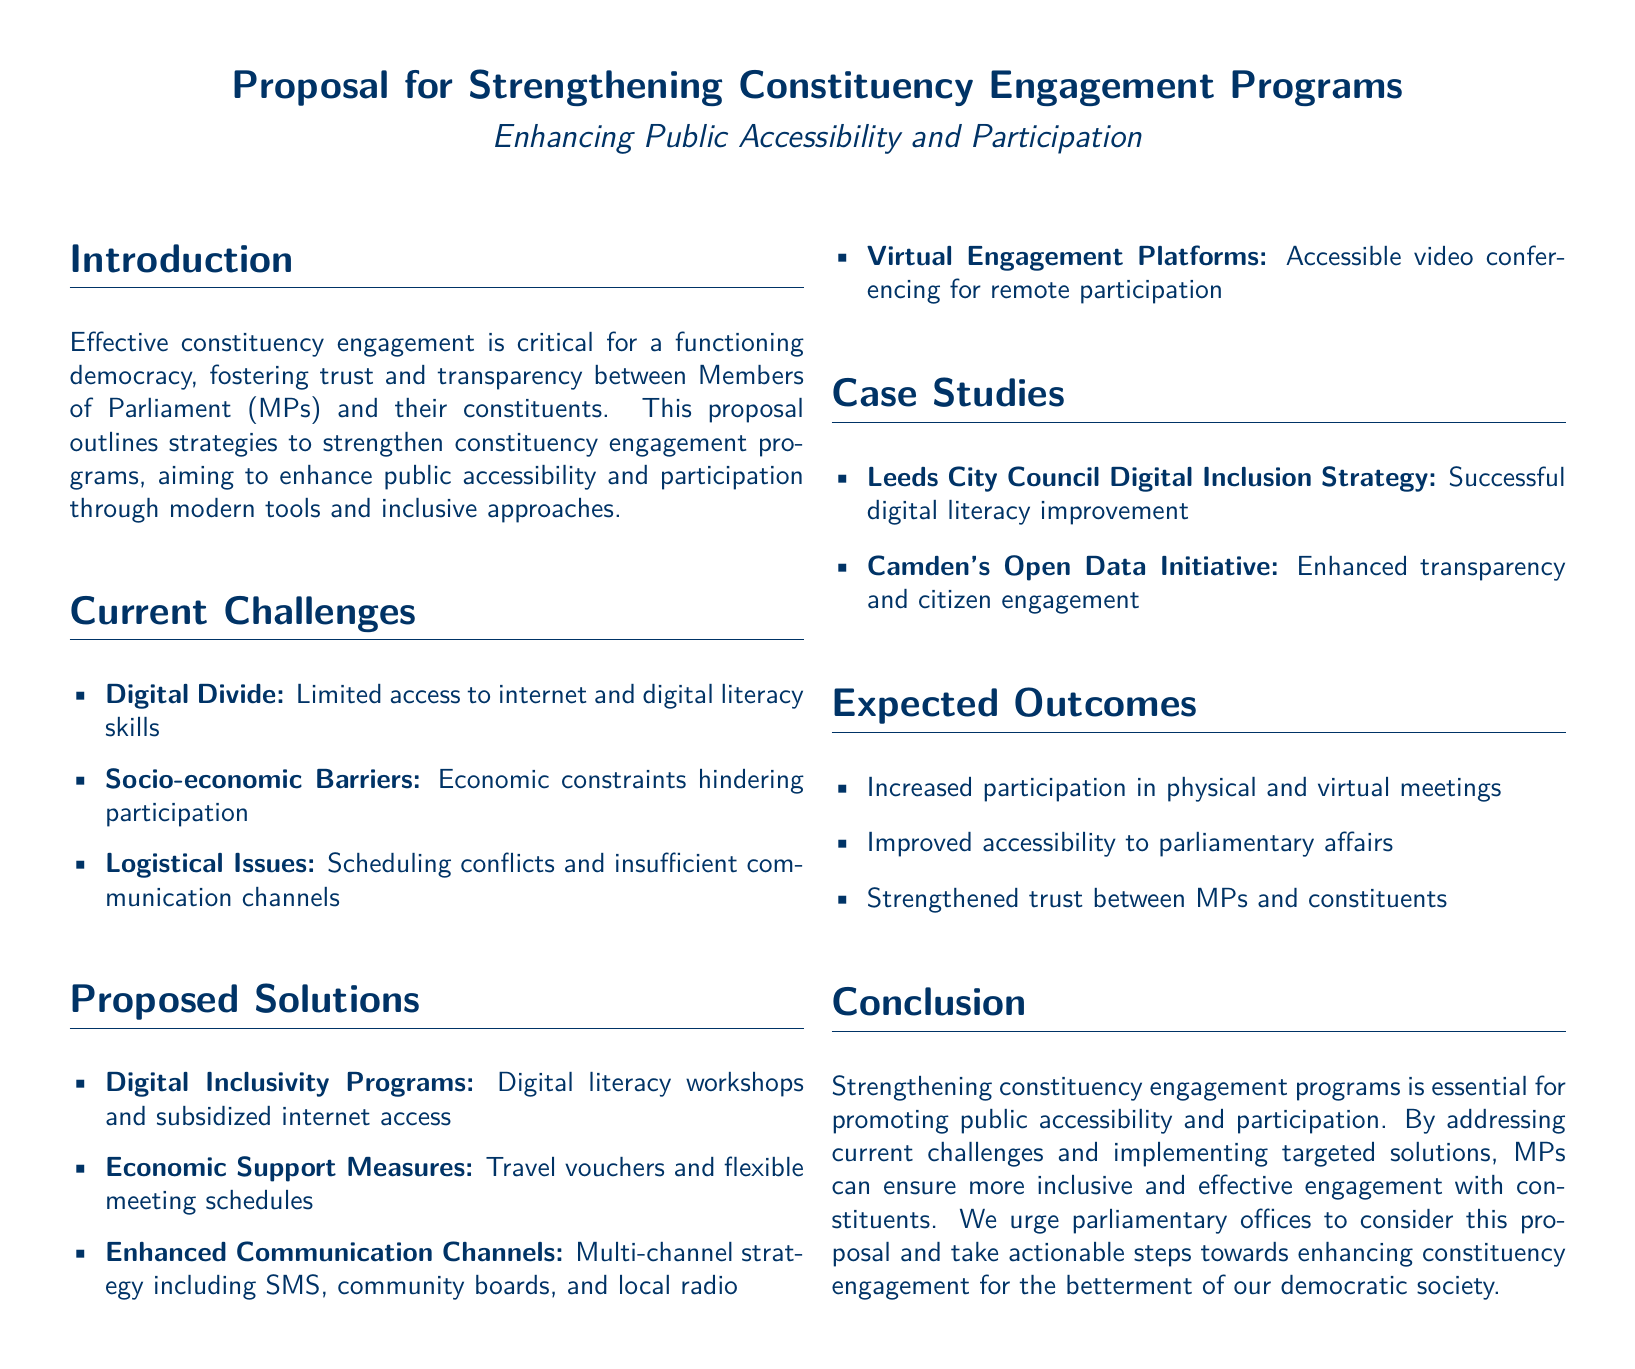What is the title of the proposal? The title of the proposal can be found prominently at the top of the document, which is "Proposal for Strengthening Constituency Engagement Programs".
Answer: Proposal for Strengthening Constituency Engagement Programs What is the primary aim of the proposal? The primary aim of the proposal is outlined in the introduction as enhancing public accessibility and participation.
Answer: Enhancing Public Accessibility and Participation What is one of the current challenges mentioned? One current challenge is listed in the "Current Challenges" section of the document as "Digital Divide".
Answer: Digital Divide What type of support is proposed to address economic barriers? The proposal suggests "Travel vouchers" to help address economic constraints on participation.
Answer: Travel vouchers Which council's strategy is mentioned as a case study? The proposal mentions "Leeds City Council Digital Inclusion Strategy" as a successful case study.
Answer: Leeds City Council Digital Inclusion Strategy How many proposed solutions are listed in the document? The number of proposed solutions can be counted in the "Proposed Solutions" section, which lists four distinct solutions.
Answer: Four What is the anticipated outcome related to trust? The expected outcome related to trust describes a strengthened relationship between MPs and constituents.
Answer: Strengthened trust What is one recommended engagement method mentioned? The proposal recommends "Virtual Engagement Platforms" for enhanced constituent participation.
Answer: Virtual Engagement Platforms What does the proposal urge parliamentary offices to do? The proposal urges parliamentary offices to take actionable steps towards strengthening engagement programs.
Answer: Take actionable steps 